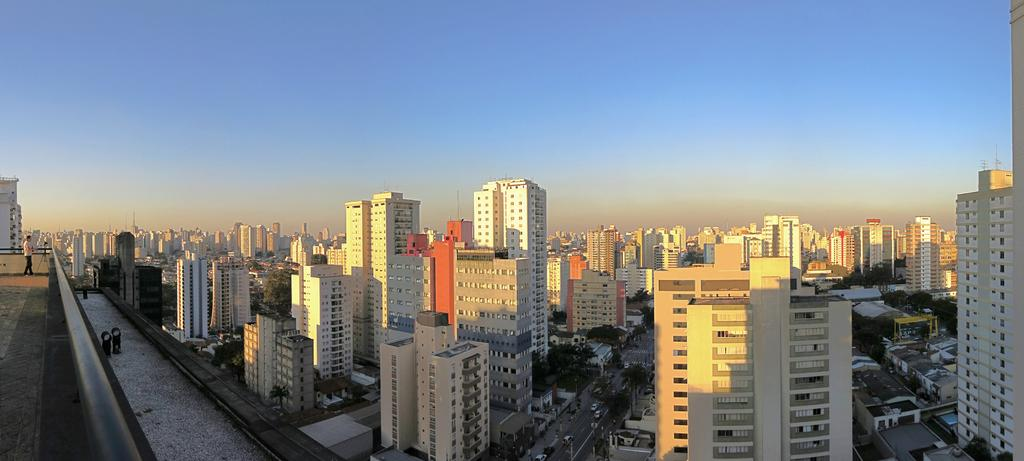What type of structures can be seen in the image? There are many buildings in the image. What else is present in the image besides the buildings? There is a road in the image, and vehicles are on the road. Can you describe the person in the image? A person is standing on the left side of the image. How would you describe the weather based on the image? The sky is clear in the image, suggesting good weather. What type of beast can be seen pulling a cart in the image? There is no beast pulling a cart in the image; it features vehicles on the road. How many bikes are visible in the image? There is no mention of bikes in the image; it only mentions vehicles on the road. 